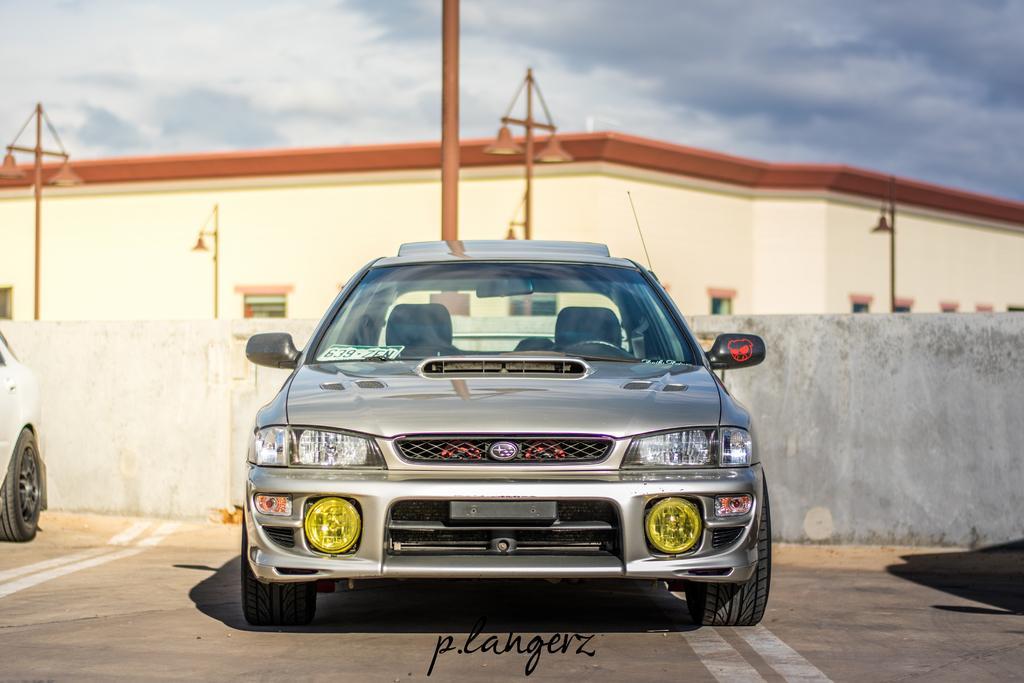Could you give a brief overview of what you see in this image? In this image we can see two vehicles on the ground, there are some poles, lights, windows and a building, in the background we can see the sky with clouds. 